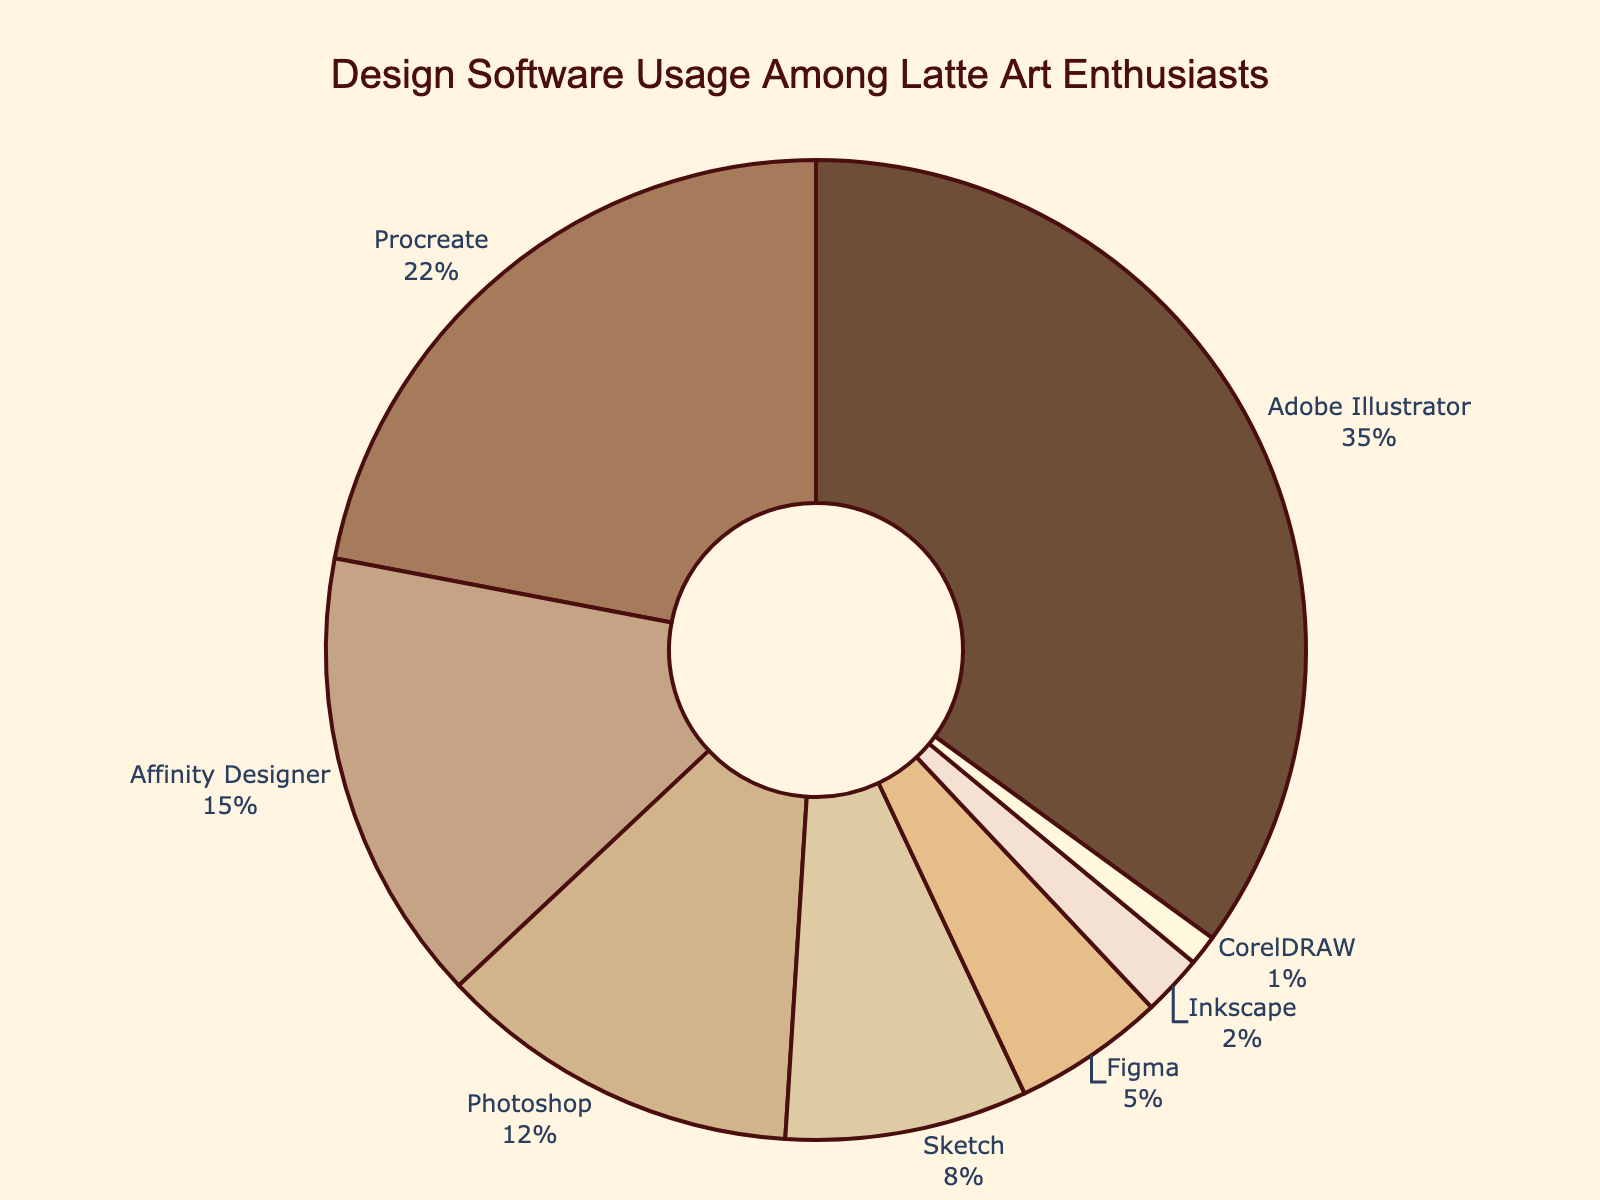Which software has the highest usage among latte art enthusiasts? By looking at the percentages on the pie chart, Adobe Illustrator has the highest value, which is 35%.
Answer: Adobe Illustrator Which software is least used by latte art enthusiasts? The smallest percentage on the pie chart is CorelDRAW with 1%.
Answer: CorelDRAW What percentage of latte art enthusiasts use Adobe Illustrator and Procreate combined? Add the percentages of Adobe Illustrator and Procreate: 35% + 22% = 57%.
Answer: 57% Which software has a usage percentage greater than 20% but less than 30%? Only Procreate fits this description with 22%.
Answer: Procreate How much more popular is Sketch compared to Figma? Subtract Figma's percentage from Sketch's: 8% - 5% = 3%.
Answer: 3% List all software applications that have a usage percentage less than 10%. The pie chart shows Sketch (8%), Figma (5%), Inkscape (2%), and CorelDRAW (1%) all have percentages less than 10%.
Answer: Sketch, Figma, Inkscape, CorelDRAW What is the difference in percentage between Adobe Illustrator and Photoshop? Subtract Photoshop's percentage from Adobe Illustrator's: 35% - 12% = 23%.
Answer: 23% Which color represents Procreate on the pie chart? Procreate is the second slice in the legend and the chart, which is colored in a lighter brown shade.
Answer: Lighter brown Rank the top three most used software among latte art enthusiasts. The pie chart shows the top three software are Adobe Illustrator (35%), Procreate (22%), and Affinity Designer (15%).
Answer: Adobe Illustrator, Procreate, Affinity Designer If you sum the percentages of Affinity Designer, Photoshop, and Sketch, how much is it in total? Adding the percentages together: 15% + 12% + 8% = 35%.
Answer: 35% 